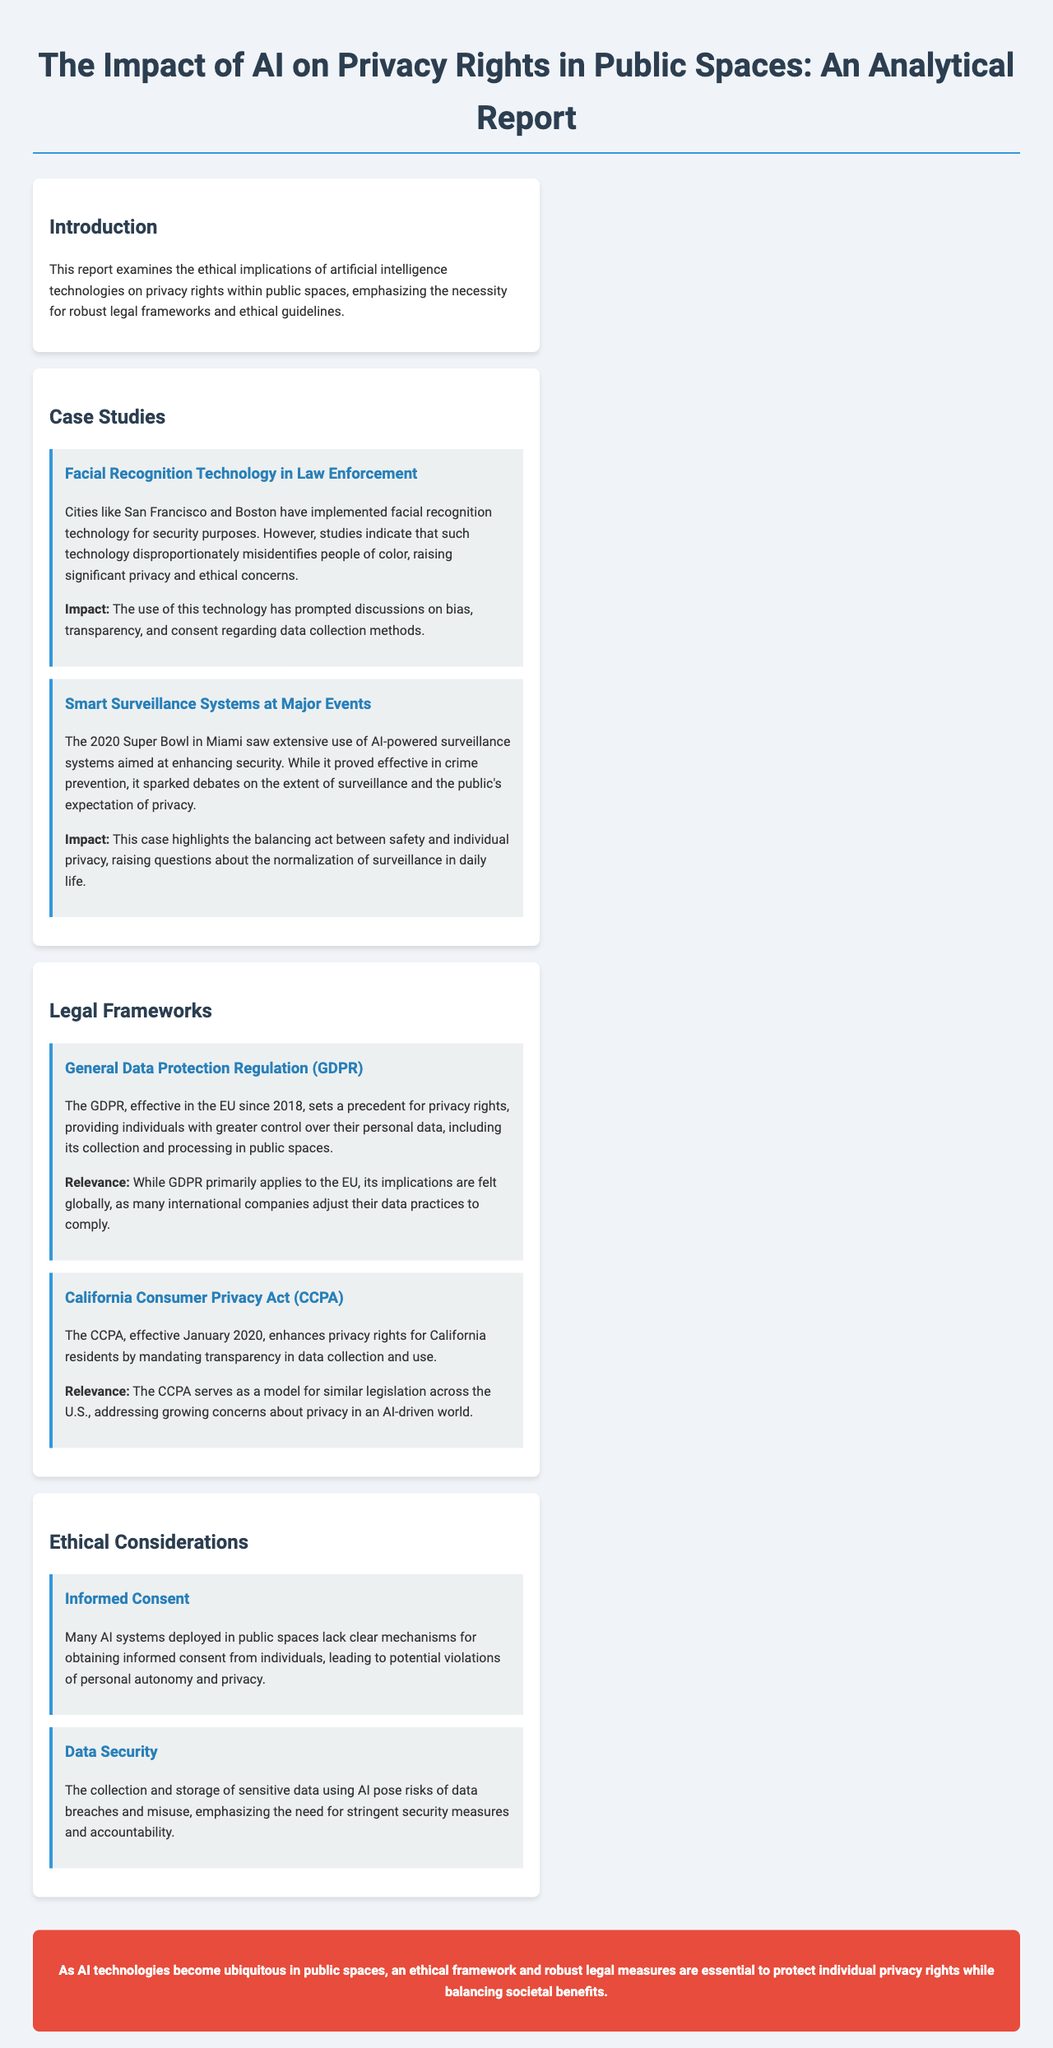What are the cities mentioned that use facial recognition technology? The document states that San Francisco and Boston have implemented facial recognition technology for security purposes.
Answer: San Francisco and Boston What is the title of the report? The title is prominently displayed at the beginning of the document.
Answer: The Impact of AI on Privacy Rights in Public Spaces What legal framework is effective in the EU since 2018? The document introduces the General Data Protection Regulation as a significant legal framework in the EU.
Answer: General Data Protection Regulation What is the focus of the ethical consideration on informed consent? The document discusses the lack of clear mechanisms for obtaining informed consent in AI systems deployed in public spaces.
Answer: Lack of clear mechanisms Which major event used smart surveillance systems as per the report? The report mentions the 2020 Super Bowl as an event where extensive AI-powered surveillance was employed.
Answer: 2020 Super Bowl How many case studies are included in the report? The report lists two case studies under the case studies section, indicating the number of studies included.
Answer: Two What does CCPA stand for? The document describes the California Consumer Privacy Act, referring to it by its initials.
Answer: CCPA What is emphasized as necessary to protect privacy rights? The conclusion states the need for an ethical framework and robust legal measures to protect individual privacy.
Answer: Ethical framework and robust legal measures 